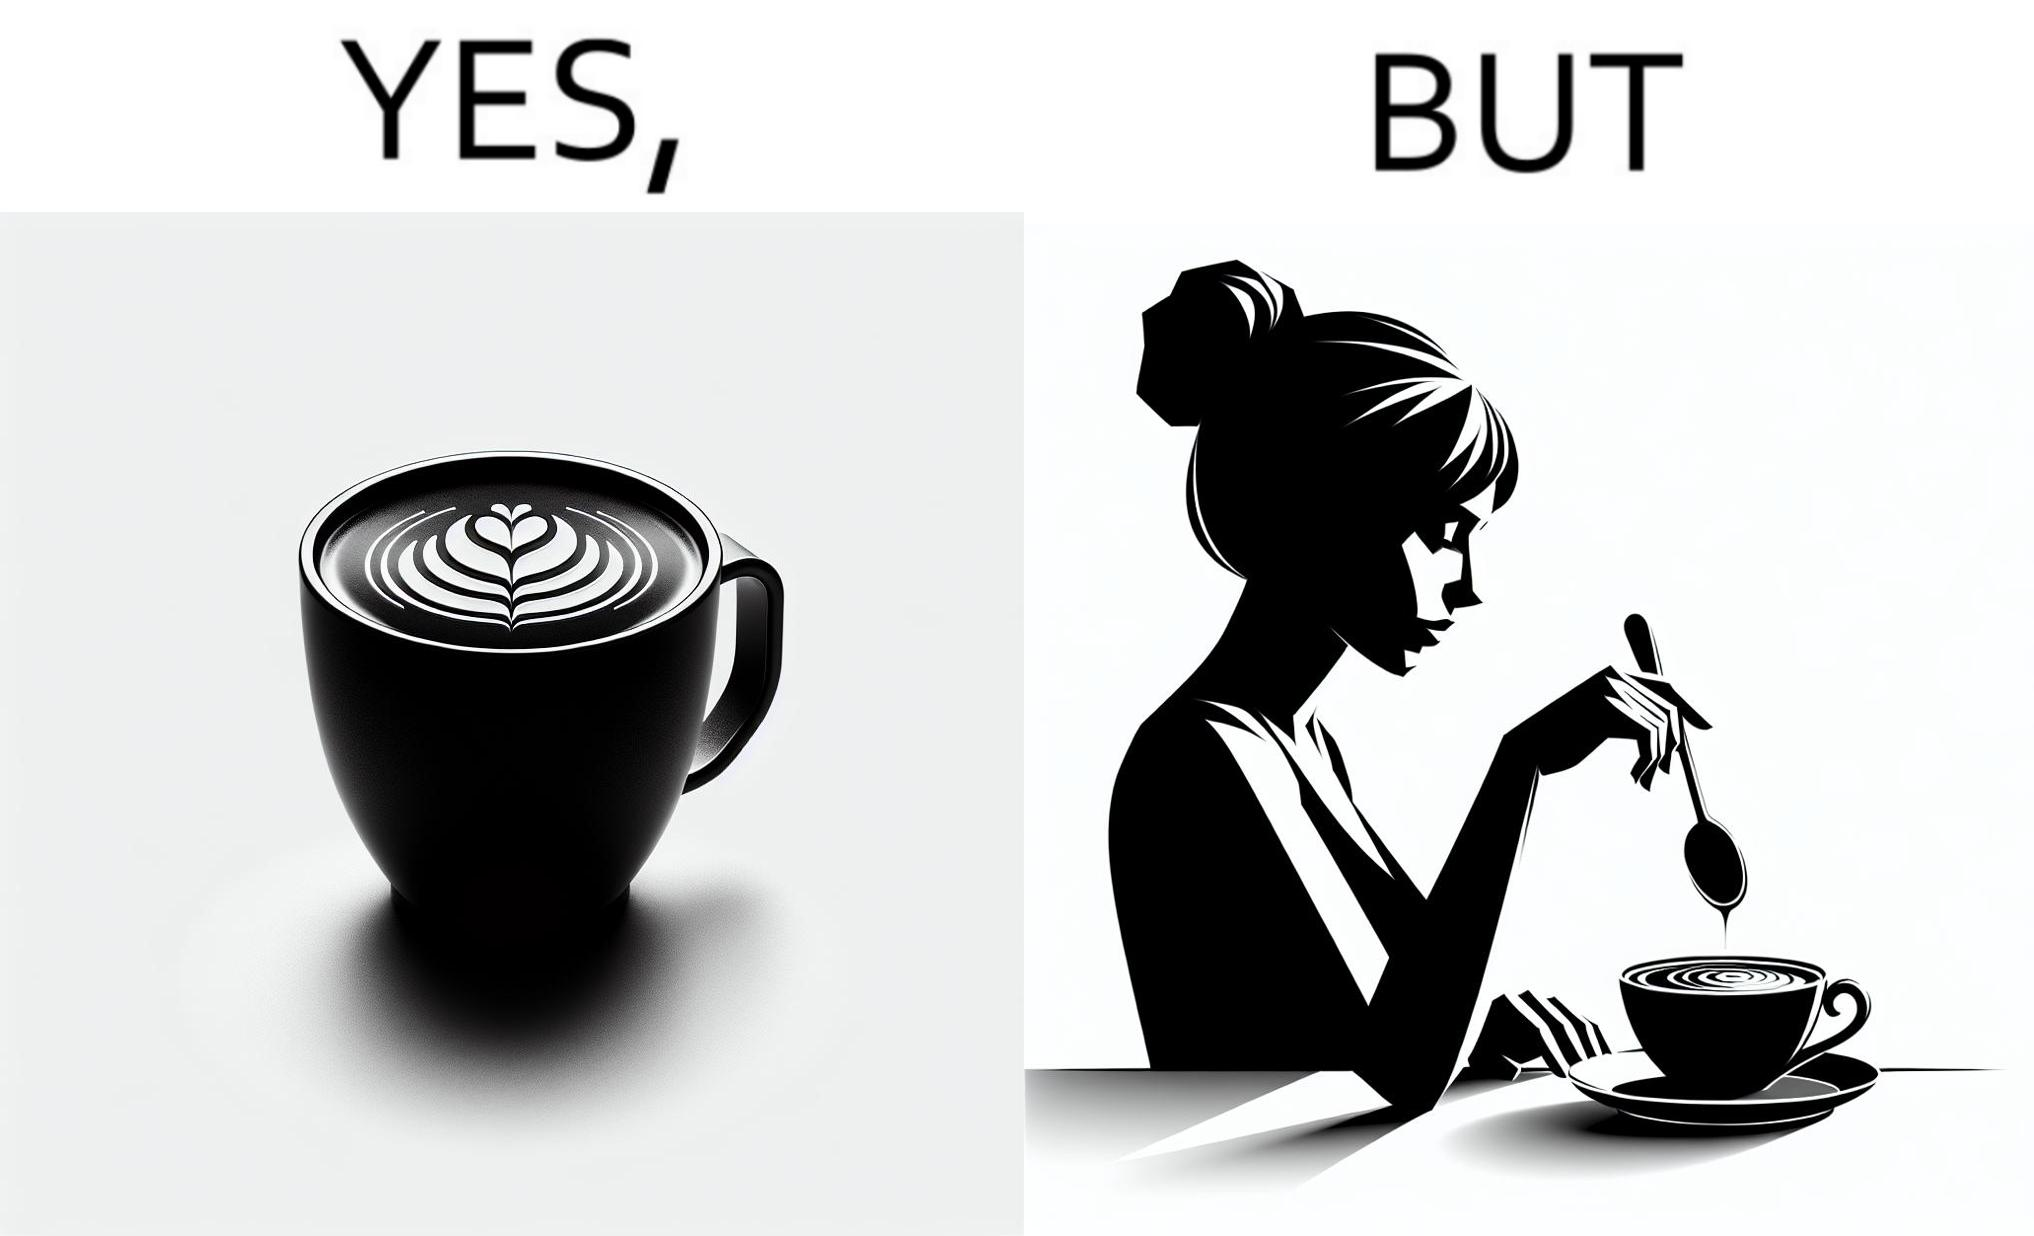Does this image contain satire or humor? Yes, this image is satirical. 